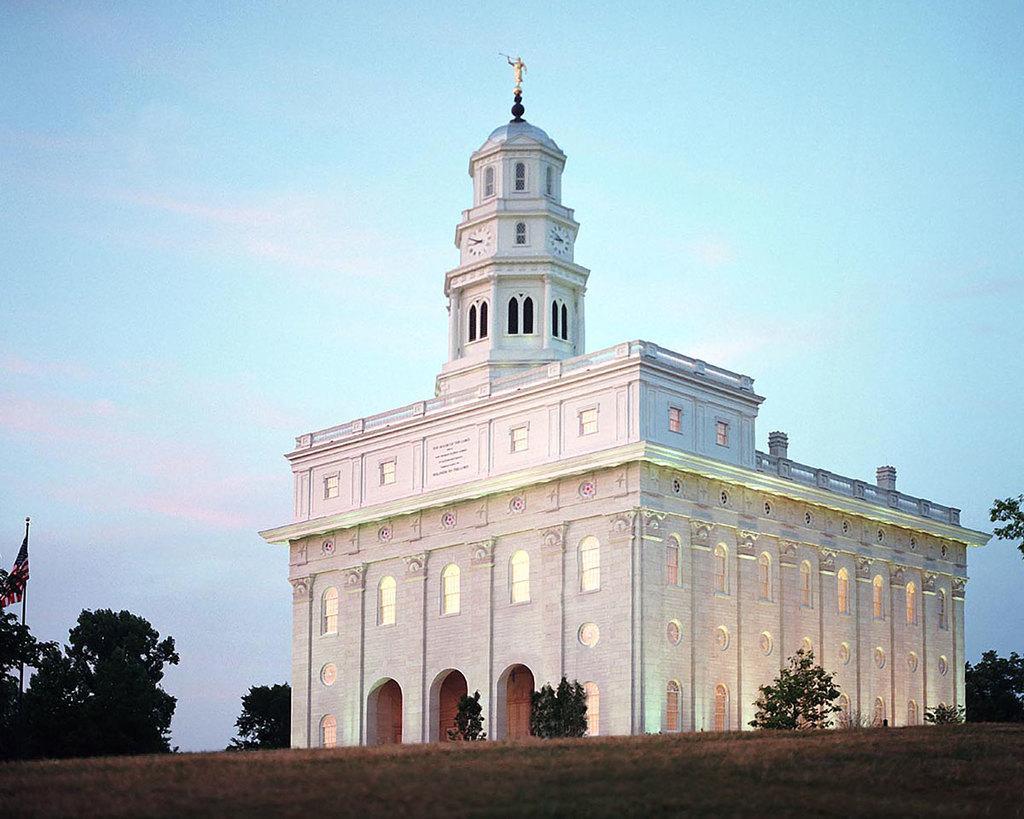Can you describe this image briefly? In this picture, we can see a building and in front of the building there are trees, a pole with a flag and behind the building there is a sky. 